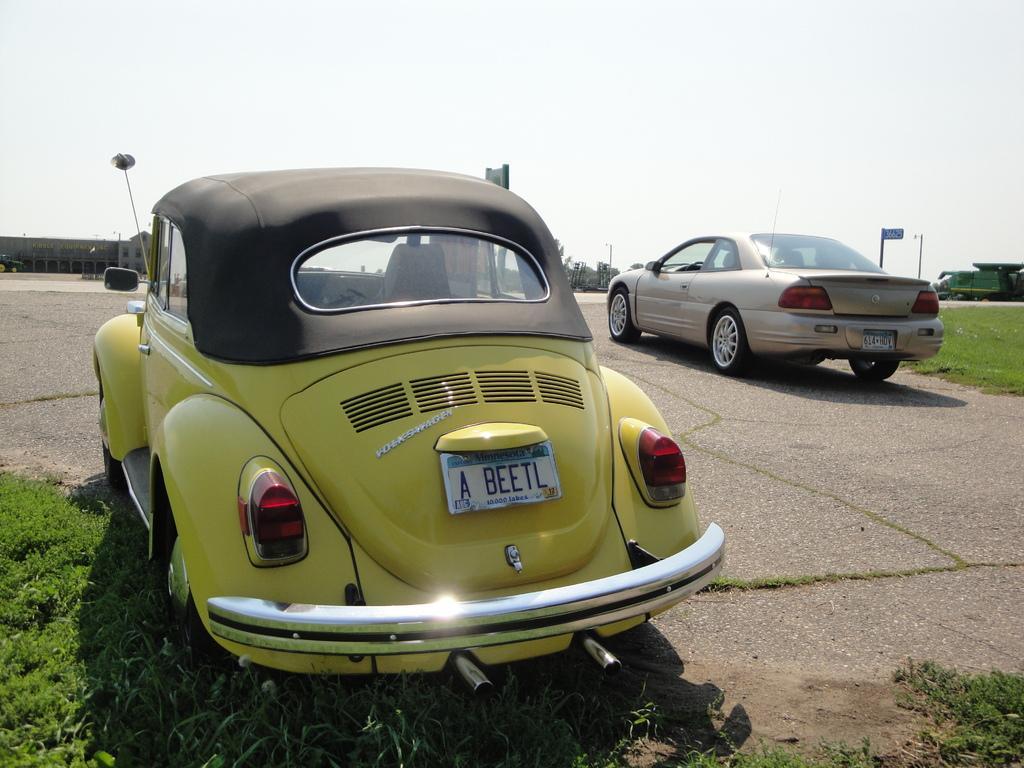Could you give a brief overview of what you see in this image? In this image, we can see vehicles on the road and in the background, there are buildings and poles and we can see some trees. At the bottom, there is ground covered with grass. 